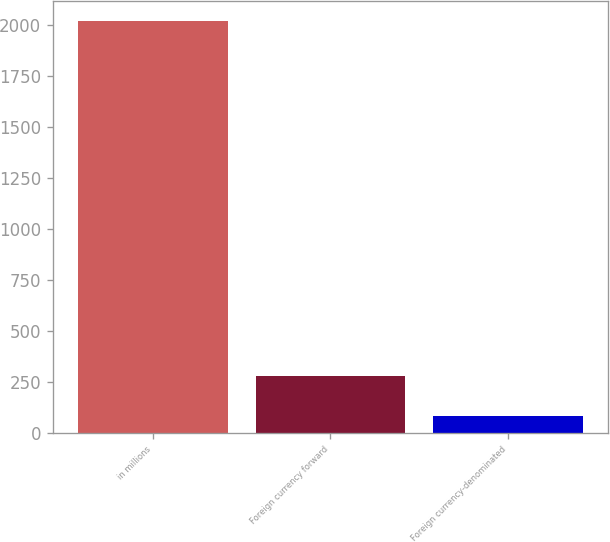Convert chart. <chart><loc_0><loc_0><loc_500><loc_500><bar_chart><fcel>in millions<fcel>Foreign currency forward<fcel>Foreign currency-denominated<nl><fcel>2016<fcel>278.1<fcel>85<nl></chart> 